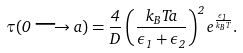Convert formula to latex. <formula><loc_0><loc_0><loc_500><loc_500>\tau ( 0 \longrightarrow a ) = \frac { 4 } { D } \left ( \frac { k _ { B } T a } { \epsilon _ { 1 } + \epsilon _ { 2 } } \right ) ^ { 2 } e ^ { \frac { \epsilon _ { 1 } } { k _ { B } T } } .</formula> 